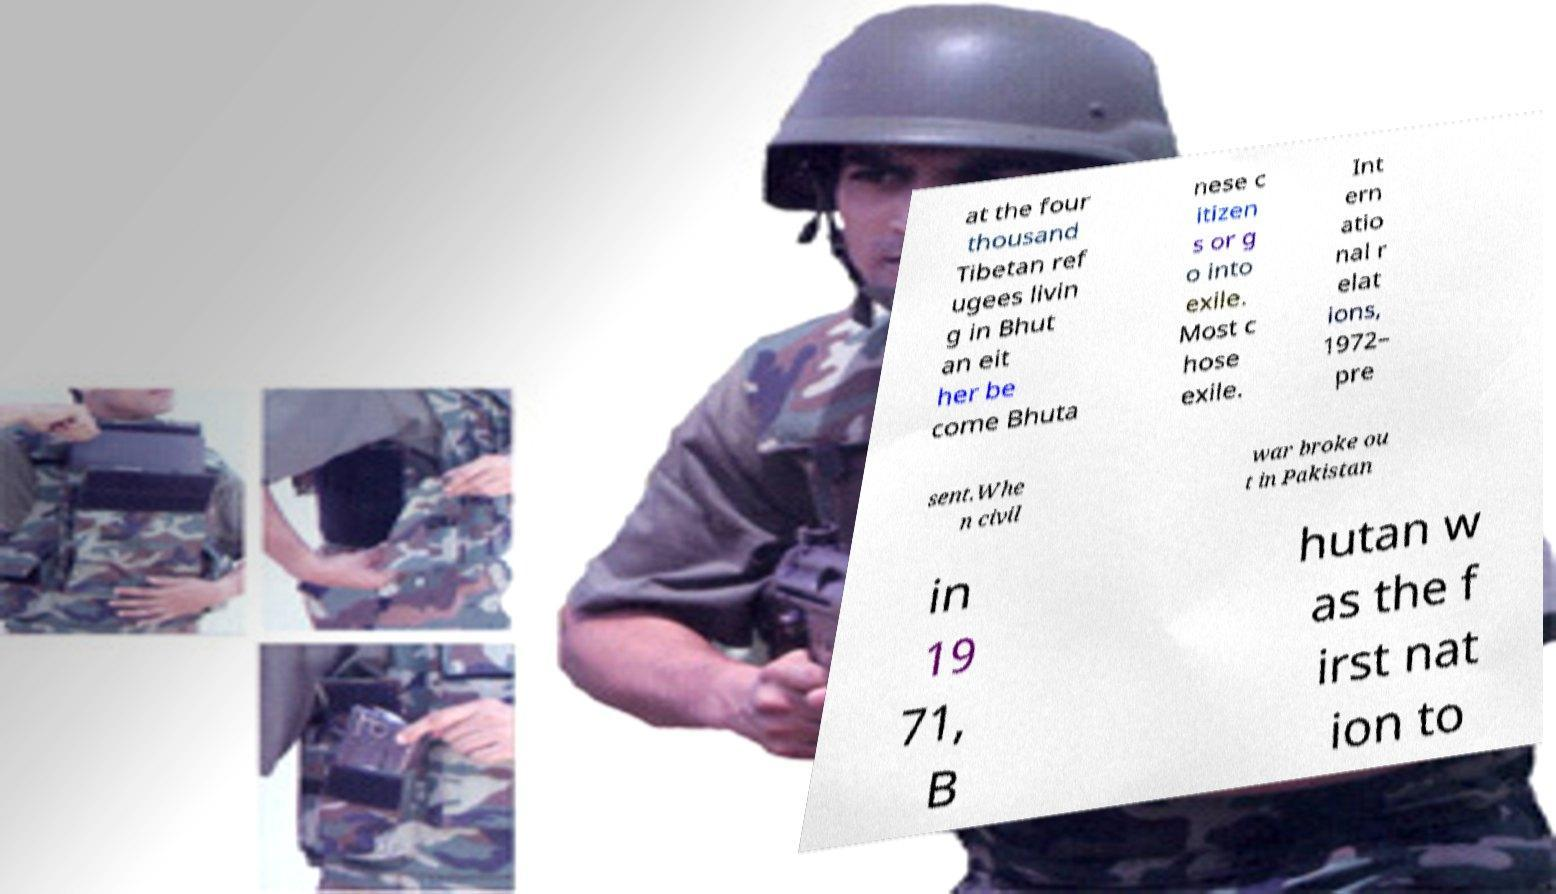Can you accurately transcribe the text from the provided image for me? at the four thousand Tibetan ref ugees livin g in Bhut an eit her be come Bhuta nese c itizen s or g o into exile. Most c hose exile. Int ern atio nal r elat ions, 1972– pre sent.Whe n civil war broke ou t in Pakistan in 19 71, B hutan w as the f irst nat ion to 